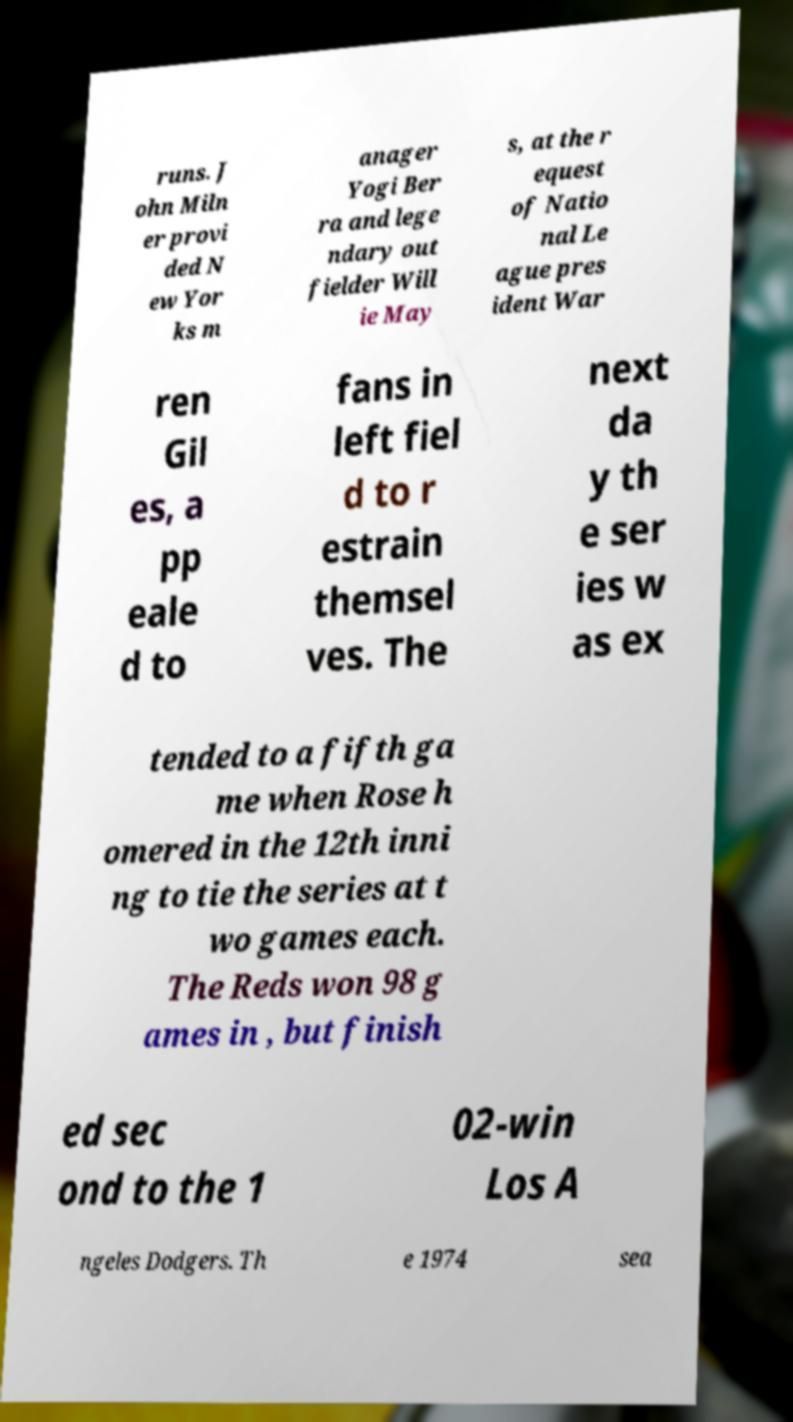For documentation purposes, I need the text within this image transcribed. Could you provide that? runs. J ohn Miln er provi ded N ew Yor ks m anager Yogi Ber ra and lege ndary out fielder Will ie May s, at the r equest of Natio nal Le ague pres ident War ren Gil es, a pp eale d to fans in left fiel d to r estrain themsel ves. The next da y th e ser ies w as ex tended to a fifth ga me when Rose h omered in the 12th inni ng to tie the series at t wo games each. The Reds won 98 g ames in , but finish ed sec ond to the 1 02-win Los A ngeles Dodgers. Th e 1974 sea 